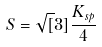<formula> <loc_0><loc_0><loc_500><loc_500>S = \sqrt { [ } 3 ] { \frac { K _ { s p } } { 4 } }</formula> 